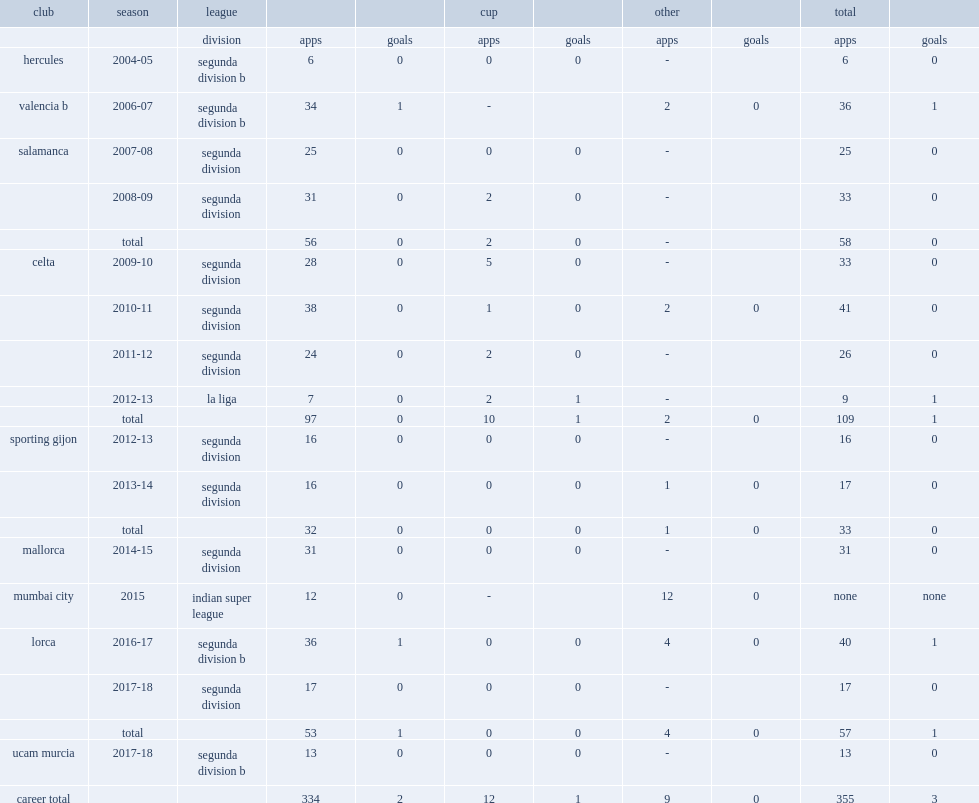Which club did bustos play for in 2015? Mumbai city. 